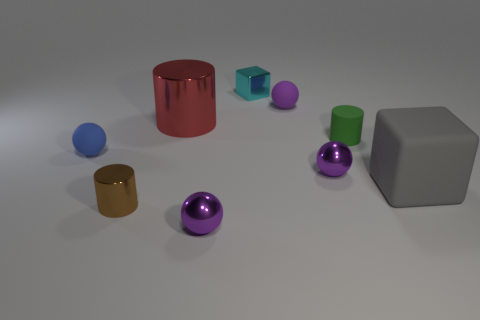Are there any patterns or consistencies in the arrangement of objects? Yes, there's a noticeable pattern in terms of shapes being grouped together. The cylinders are aligned diagonally across the scene, and the spheres are positioned closer to each other. The cubes, while the same shape, are different in size and are placed apart from each other. Do the sizes of these objects indicate anything particular? While the sizes of the objects may not convey a specific message, they provide a good sense of scale and variety. The objects range from small to large, creating a visual balance within the composition and demonstrating how objects of different sizes can coexist harmoniously in a given space. 